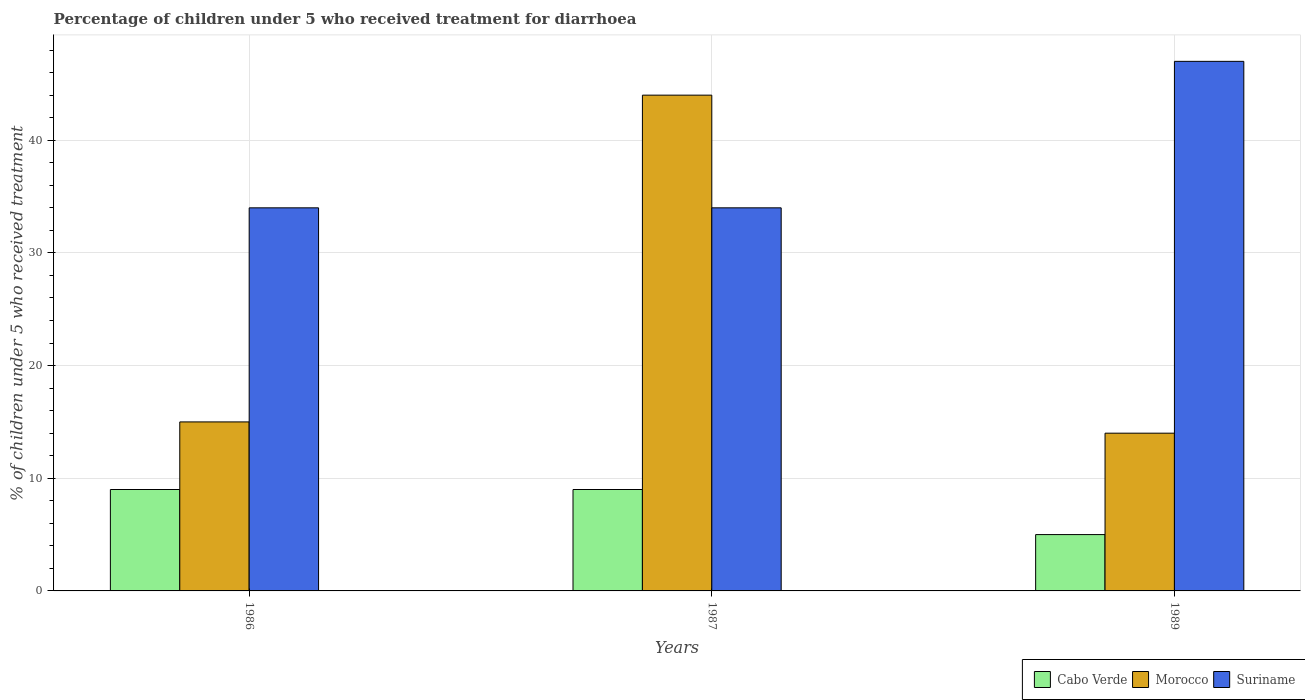How many different coloured bars are there?
Make the answer very short. 3. How many groups of bars are there?
Give a very brief answer. 3. Are the number of bars on each tick of the X-axis equal?
Provide a short and direct response. Yes. How many bars are there on the 1st tick from the right?
Give a very brief answer. 3. What is the label of the 1st group of bars from the left?
Offer a terse response. 1986. Across all years, what is the maximum percentage of children who received treatment for diarrhoea  in Suriname?
Your answer should be very brief. 47. In which year was the percentage of children who received treatment for diarrhoea  in Morocco maximum?
Offer a very short reply. 1987. What is the average percentage of children who received treatment for diarrhoea  in Morocco per year?
Make the answer very short. 24.33. What is the difference between the highest and the second highest percentage of children who received treatment for diarrhoea  in Morocco?
Your answer should be compact. 29. What is the difference between the highest and the lowest percentage of children who received treatment for diarrhoea  in Morocco?
Your answer should be compact. 30. In how many years, is the percentage of children who received treatment for diarrhoea  in Morocco greater than the average percentage of children who received treatment for diarrhoea  in Morocco taken over all years?
Your answer should be compact. 1. What does the 2nd bar from the left in 1989 represents?
Make the answer very short. Morocco. What does the 3rd bar from the right in 1986 represents?
Your response must be concise. Cabo Verde. How many bars are there?
Your response must be concise. 9. Are all the bars in the graph horizontal?
Offer a terse response. No. How many years are there in the graph?
Offer a terse response. 3. What is the difference between two consecutive major ticks on the Y-axis?
Your response must be concise. 10. Does the graph contain grids?
Give a very brief answer. Yes. How many legend labels are there?
Make the answer very short. 3. What is the title of the graph?
Offer a terse response. Percentage of children under 5 who received treatment for diarrhoea. Does "Haiti" appear as one of the legend labels in the graph?
Provide a short and direct response. No. What is the label or title of the Y-axis?
Ensure brevity in your answer.  % of children under 5 who received treatment. What is the % of children under 5 who received treatment of Cabo Verde in 1986?
Your response must be concise. 9. What is the % of children under 5 who received treatment of Morocco in 1986?
Make the answer very short. 15. What is the % of children under 5 who received treatment in Cabo Verde in 1987?
Provide a succinct answer. 9. What is the % of children under 5 who received treatment in Morocco in 1987?
Provide a short and direct response. 44. What is the % of children under 5 who received treatment of Suriname in 1987?
Keep it short and to the point. 34. What is the % of children under 5 who received treatment of Cabo Verde in 1989?
Your answer should be very brief. 5. Across all years, what is the minimum % of children under 5 who received treatment of Morocco?
Keep it short and to the point. 14. Across all years, what is the minimum % of children under 5 who received treatment of Suriname?
Provide a succinct answer. 34. What is the total % of children under 5 who received treatment of Cabo Verde in the graph?
Your answer should be compact. 23. What is the total % of children under 5 who received treatment of Morocco in the graph?
Keep it short and to the point. 73. What is the total % of children under 5 who received treatment in Suriname in the graph?
Make the answer very short. 115. What is the difference between the % of children under 5 who received treatment of Cabo Verde in 1986 and that in 1989?
Offer a terse response. 4. What is the difference between the % of children under 5 who received treatment of Suriname in 1986 and that in 1989?
Your response must be concise. -13. What is the difference between the % of children under 5 who received treatment of Morocco in 1987 and that in 1989?
Your response must be concise. 30. What is the difference between the % of children under 5 who received treatment of Cabo Verde in 1986 and the % of children under 5 who received treatment of Morocco in 1987?
Your response must be concise. -35. What is the difference between the % of children under 5 who received treatment in Cabo Verde in 1986 and the % of children under 5 who received treatment in Morocco in 1989?
Your answer should be very brief. -5. What is the difference between the % of children under 5 who received treatment of Cabo Verde in 1986 and the % of children under 5 who received treatment of Suriname in 1989?
Your response must be concise. -38. What is the difference between the % of children under 5 who received treatment in Morocco in 1986 and the % of children under 5 who received treatment in Suriname in 1989?
Make the answer very short. -32. What is the difference between the % of children under 5 who received treatment in Cabo Verde in 1987 and the % of children under 5 who received treatment in Suriname in 1989?
Provide a succinct answer. -38. What is the average % of children under 5 who received treatment of Cabo Verde per year?
Make the answer very short. 7.67. What is the average % of children under 5 who received treatment in Morocco per year?
Provide a succinct answer. 24.33. What is the average % of children under 5 who received treatment of Suriname per year?
Give a very brief answer. 38.33. In the year 1986, what is the difference between the % of children under 5 who received treatment in Cabo Verde and % of children under 5 who received treatment in Morocco?
Provide a short and direct response. -6. In the year 1987, what is the difference between the % of children under 5 who received treatment of Cabo Verde and % of children under 5 who received treatment of Morocco?
Keep it short and to the point. -35. In the year 1987, what is the difference between the % of children under 5 who received treatment of Morocco and % of children under 5 who received treatment of Suriname?
Make the answer very short. 10. In the year 1989, what is the difference between the % of children under 5 who received treatment in Cabo Verde and % of children under 5 who received treatment in Morocco?
Your response must be concise. -9. In the year 1989, what is the difference between the % of children under 5 who received treatment in Cabo Verde and % of children under 5 who received treatment in Suriname?
Your answer should be compact. -42. In the year 1989, what is the difference between the % of children under 5 who received treatment in Morocco and % of children under 5 who received treatment in Suriname?
Offer a very short reply. -33. What is the ratio of the % of children under 5 who received treatment in Morocco in 1986 to that in 1987?
Your answer should be compact. 0.34. What is the ratio of the % of children under 5 who received treatment of Suriname in 1986 to that in 1987?
Offer a very short reply. 1. What is the ratio of the % of children under 5 who received treatment in Morocco in 1986 to that in 1989?
Offer a terse response. 1.07. What is the ratio of the % of children under 5 who received treatment of Suriname in 1986 to that in 1989?
Keep it short and to the point. 0.72. What is the ratio of the % of children under 5 who received treatment of Cabo Verde in 1987 to that in 1989?
Your answer should be compact. 1.8. What is the ratio of the % of children under 5 who received treatment in Morocco in 1987 to that in 1989?
Provide a succinct answer. 3.14. What is the ratio of the % of children under 5 who received treatment of Suriname in 1987 to that in 1989?
Provide a short and direct response. 0.72. What is the difference between the highest and the second highest % of children under 5 who received treatment of Cabo Verde?
Your response must be concise. 0. What is the difference between the highest and the lowest % of children under 5 who received treatment in Cabo Verde?
Give a very brief answer. 4. What is the difference between the highest and the lowest % of children under 5 who received treatment in Morocco?
Keep it short and to the point. 30. 